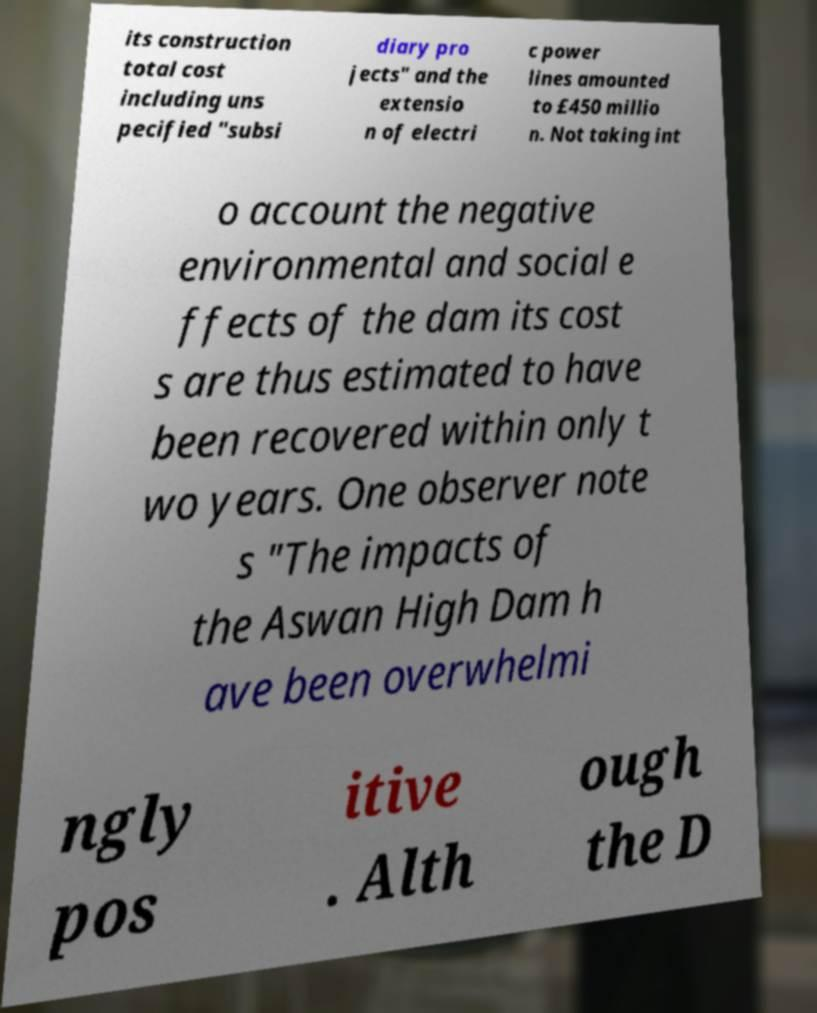Please read and relay the text visible in this image. What does it say? its construction total cost including uns pecified "subsi diary pro jects" and the extensio n of electri c power lines amounted to £450 millio n. Not taking int o account the negative environmental and social e ffects of the dam its cost s are thus estimated to have been recovered within only t wo years. One observer note s "The impacts of the Aswan High Dam h ave been overwhelmi ngly pos itive . Alth ough the D 